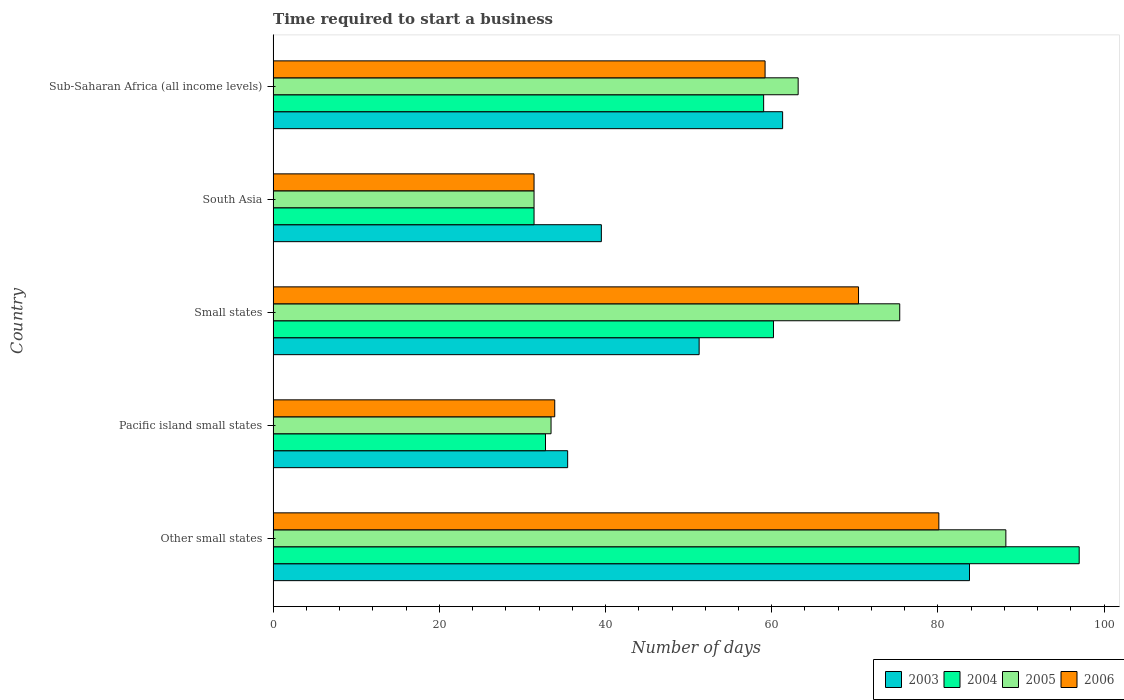How many groups of bars are there?
Your answer should be very brief. 5. Are the number of bars on each tick of the Y-axis equal?
Ensure brevity in your answer.  Yes. How many bars are there on the 2nd tick from the top?
Make the answer very short. 4. What is the label of the 2nd group of bars from the top?
Offer a terse response. South Asia. What is the number of days required to start a business in 2005 in Sub-Saharan Africa (all income levels)?
Offer a very short reply. 63.18. Across all countries, what is the maximum number of days required to start a business in 2006?
Ensure brevity in your answer.  80.11. Across all countries, what is the minimum number of days required to start a business in 2005?
Keep it short and to the point. 31.4. In which country was the number of days required to start a business in 2005 maximum?
Provide a succinct answer. Other small states. In which country was the number of days required to start a business in 2005 minimum?
Offer a very short reply. South Asia. What is the total number of days required to start a business in 2004 in the graph?
Ensure brevity in your answer.  280.42. What is the difference between the number of days required to start a business in 2005 in Pacific island small states and that in Small states?
Provide a short and direct response. -41.96. What is the difference between the number of days required to start a business in 2005 in Pacific island small states and the number of days required to start a business in 2003 in Other small states?
Provide a short and direct response. -50.36. What is the average number of days required to start a business in 2006 per country?
Provide a succinct answer. 55.01. What is the difference between the number of days required to start a business in 2006 and number of days required to start a business in 2004 in South Asia?
Make the answer very short. 0. What is the ratio of the number of days required to start a business in 2006 in Small states to that in South Asia?
Provide a short and direct response. 2.24. Is the number of days required to start a business in 2005 in South Asia less than that in Sub-Saharan Africa (all income levels)?
Offer a very short reply. Yes. What is the difference between the highest and the second highest number of days required to start a business in 2006?
Offer a very short reply. 9.66. What is the difference between the highest and the lowest number of days required to start a business in 2004?
Your answer should be very brief. 65.6. Is it the case that in every country, the sum of the number of days required to start a business in 2005 and number of days required to start a business in 2004 is greater than the sum of number of days required to start a business in 2006 and number of days required to start a business in 2003?
Your answer should be compact. No. How many bars are there?
Offer a very short reply. 20. How many countries are there in the graph?
Offer a very short reply. 5. What is the difference between two consecutive major ticks on the X-axis?
Your answer should be very brief. 20. Are the values on the major ticks of X-axis written in scientific E-notation?
Provide a succinct answer. No. Does the graph contain grids?
Ensure brevity in your answer.  No. What is the title of the graph?
Offer a very short reply. Time required to start a business. What is the label or title of the X-axis?
Keep it short and to the point. Number of days. What is the label or title of the Y-axis?
Offer a very short reply. Country. What is the Number of days in 2003 in Other small states?
Your answer should be compact. 83.8. What is the Number of days in 2004 in Other small states?
Ensure brevity in your answer.  97. What is the Number of days in 2005 in Other small states?
Provide a short and direct response. 88.18. What is the Number of days of 2006 in Other small states?
Offer a terse response. 80.11. What is the Number of days of 2003 in Pacific island small states?
Give a very brief answer. 35.44. What is the Number of days in 2004 in Pacific island small states?
Provide a succinct answer. 32.78. What is the Number of days in 2005 in Pacific island small states?
Your answer should be very brief. 33.44. What is the Number of days of 2006 in Pacific island small states?
Make the answer very short. 33.89. What is the Number of days of 2003 in Small states?
Your response must be concise. 51.27. What is the Number of days in 2004 in Small states?
Your answer should be compact. 60.21. What is the Number of days in 2005 in Small states?
Give a very brief answer. 75.41. What is the Number of days of 2006 in Small states?
Provide a short and direct response. 70.45. What is the Number of days in 2003 in South Asia?
Your answer should be compact. 39.5. What is the Number of days in 2004 in South Asia?
Provide a short and direct response. 31.4. What is the Number of days of 2005 in South Asia?
Your response must be concise. 31.4. What is the Number of days of 2006 in South Asia?
Provide a succinct answer. 31.4. What is the Number of days of 2003 in Sub-Saharan Africa (all income levels)?
Your answer should be compact. 61.31. What is the Number of days of 2004 in Sub-Saharan Africa (all income levels)?
Provide a short and direct response. 59.03. What is the Number of days in 2005 in Sub-Saharan Africa (all income levels)?
Keep it short and to the point. 63.18. What is the Number of days of 2006 in Sub-Saharan Africa (all income levels)?
Ensure brevity in your answer.  59.2. Across all countries, what is the maximum Number of days in 2003?
Your answer should be compact. 83.8. Across all countries, what is the maximum Number of days of 2004?
Your response must be concise. 97. Across all countries, what is the maximum Number of days in 2005?
Offer a terse response. 88.18. Across all countries, what is the maximum Number of days of 2006?
Provide a succinct answer. 80.11. Across all countries, what is the minimum Number of days of 2003?
Give a very brief answer. 35.44. Across all countries, what is the minimum Number of days of 2004?
Your answer should be compact. 31.4. Across all countries, what is the minimum Number of days in 2005?
Your answer should be compact. 31.4. Across all countries, what is the minimum Number of days of 2006?
Provide a short and direct response. 31.4. What is the total Number of days in 2003 in the graph?
Your answer should be very brief. 271.32. What is the total Number of days of 2004 in the graph?
Your answer should be very brief. 280.42. What is the total Number of days of 2005 in the graph?
Your answer should be compact. 291.61. What is the total Number of days in 2006 in the graph?
Keep it short and to the point. 275.05. What is the difference between the Number of days in 2003 in Other small states and that in Pacific island small states?
Offer a terse response. 48.36. What is the difference between the Number of days in 2004 in Other small states and that in Pacific island small states?
Ensure brevity in your answer.  64.22. What is the difference between the Number of days in 2005 in Other small states and that in Pacific island small states?
Ensure brevity in your answer.  54.73. What is the difference between the Number of days of 2006 in Other small states and that in Pacific island small states?
Provide a short and direct response. 46.22. What is the difference between the Number of days of 2003 in Other small states and that in Small states?
Make the answer very short. 32.53. What is the difference between the Number of days in 2004 in Other small states and that in Small states?
Provide a succinct answer. 36.79. What is the difference between the Number of days of 2005 in Other small states and that in Small states?
Keep it short and to the point. 12.77. What is the difference between the Number of days in 2006 in Other small states and that in Small states?
Provide a short and direct response. 9.66. What is the difference between the Number of days in 2003 in Other small states and that in South Asia?
Provide a short and direct response. 44.3. What is the difference between the Number of days in 2004 in Other small states and that in South Asia?
Keep it short and to the point. 65.6. What is the difference between the Number of days of 2005 in Other small states and that in South Asia?
Your answer should be very brief. 56.78. What is the difference between the Number of days in 2006 in Other small states and that in South Asia?
Make the answer very short. 48.71. What is the difference between the Number of days of 2003 in Other small states and that in Sub-Saharan Africa (all income levels)?
Keep it short and to the point. 22.49. What is the difference between the Number of days in 2004 in Other small states and that in Sub-Saharan Africa (all income levels)?
Your answer should be compact. 37.97. What is the difference between the Number of days of 2005 in Other small states and that in Sub-Saharan Africa (all income levels)?
Your answer should be compact. 24.99. What is the difference between the Number of days in 2006 in Other small states and that in Sub-Saharan Africa (all income levels)?
Your response must be concise. 20.91. What is the difference between the Number of days in 2003 in Pacific island small states and that in Small states?
Provide a succinct answer. -15.82. What is the difference between the Number of days of 2004 in Pacific island small states and that in Small states?
Provide a short and direct response. -27.43. What is the difference between the Number of days of 2005 in Pacific island small states and that in Small states?
Your response must be concise. -41.96. What is the difference between the Number of days in 2006 in Pacific island small states and that in Small states?
Make the answer very short. -36.56. What is the difference between the Number of days in 2003 in Pacific island small states and that in South Asia?
Offer a very short reply. -4.06. What is the difference between the Number of days of 2004 in Pacific island small states and that in South Asia?
Your answer should be compact. 1.38. What is the difference between the Number of days in 2005 in Pacific island small states and that in South Asia?
Provide a short and direct response. 2.04. What is the difference between the Number of days of 2006 in Pacific island small states and that in South Asia?
Ensure brevity in your answer.  2.49. What is the difference between the Number of days in 2003 in Pacific island small states and that in Sub-Saharan Africa (all income levels)?
Provide a short and direct response. -25.87. What is the difference between the Number of days in 2004 in Pacific island small states and that in Sub-Saharan Africa (all income levels)?
Keep it short and to the point. -26.25. What is the difference between the Number of days in 2005 in Pacific island small states and that in Sub-Saharan Africa (all income levels)?
Make the answer very short. -29.74. What is the difference between the Number of days of 2006 in Pacific island small states and that in Sub-Saharan Africa (all income levels)?
Provide a short and direct response. -25.31. What is the difference between the Number of days in 2003 in Small states and that in South Asia?
Your answer should be compact. 11.77. What is the difference between the Number of days in 2004 in Small states and that in South Asia?
Provide a succinct answer. 28.81. What is the difference between the Number of days of 2005 in Small states and that in South Asia?
Offer a very short reply. 44.01. What is the difference between the Number of days of 2006 in Small states and that in South Asia?
Offer a terse response. 39.05. What is the difference between the Number of days of 2003 in Small states and that in Sub-Saharan Africa (all income levels)?
Your answer should be very brief. -10.05. What is the difference between the Number of days in 2004 in Small states and that in Sub-Saharan Africa (all income levels)?
Your answer should be compact. 1.18. What is the difference between the Number of days in 2005 in Small states and that in Sub-Saharan Africa (all income levels)?
Offer a terse response. 12.22. What is the difference between the Number of days in 2006 in Small states and that in Sub-Saharan Africa (all income levels)?
Provide a succinct answer. 11.25. What is the difference between the Number of days of 2003 in South Asia and that in Sub-Saharan Africa (all income levels)?
Your answer should be compact. -21.81. What is the difference between the Number of days in 2004 in South Asia and that in Sub-Saharan Africa (all income levels)?
Provide a succinct answer. -27.63. What is the difference between the Number of days of 2005 in South Asia and that in Sub-Saharan Africa (all income levels)?
Ensure brevity in your answer.  -31.78. What is the difference between the Number of days in 2006 in South Asia and that in Sub-Saharan Africa (all income levels)?
Keep it short and to the point. -27.8. What is the difference between the Number of days in 2003 in Other small states and the Number of days in 2004 in Pacific island small states?
Your response must be concise. 51.02. What is the difference between the Number of days in 2003 in Other small states and the Number of days in 2005 in Pacific island small states?
Provide a short and direct response. 50.36. What is the difference between the Number of days in 2003 in Other small states and the Number of days in 2006 in Pacific island small states?
Your answer should be compact. 49.91. What is the difference between the Number of days in 2004 in Other small states and the Number of days in 2005 in Pacific island small states?
Offer a terse response. 63.56. What is the difference between the Number of days of 2004 in Other small states and the Number of days of 2006 in Pacific island small states?
Offer a terse response. 63.11. What is the difference between the Number of days in 2005 in Other small states and the Number of days in 2006 in Pacific island small states?
Your answer should be very brief. 54.29. What is the difference between the Number of days in 2003 in Other small states and the Number of days in 2004 in Small states?
Your response must be concise. 23.59. What is the difference between the Number of days in 2003 in Other small states and the Number of days in 2005 in Small states?
Keep it short and to the point. 8.39. What is the difference between the Number of days in 2003 in Other small states and the Number of days in 2006 in Small states?
Offer a very short reply. 13.35. What is the difference between the Number of days of 2004 in Other small states and the Number of days of 2005 in Small states?
Keep it short and to the point. 21.59. What is the difference between the Number of days of 2004 in Other small states and the Number of days of 2006 in Small states?
Give a very brief answer. 26.55. What is the difference between the Number of days of 2005 in Other small states and the Number of days of 2006 in Small states?
Your response must be concise. 17.73. What is the difference between the Number of days in 2003 in Other small states and the Number of days in 2004 in South Asia?
Your answer should be compact. 52.4. What is the difference between the Number of days in 2003 in Other small states and the Number of days in 2005 in South Asia?
Keep it short and to the point. 52.4. What is the difference between the Number of days in 2003 in Other small states and the Number of days in 2006 in South Asia?
Provide a short and direct response. 52.4. What is the difference between the Number of days in 2004 in Other small states and the Number of days in 2005 in South Asia?
Make the answer very short. 65.6. What is the difference between the Number of days of 2004 in Other small states and the Number of days of 2006 in South Asia?
Your response must be concise. 65.6. What is the difference between the Number of days of 2005 in Other small states and the Number of days of 2006 in South Asia?
Provide a succinct answer. 56.78. What is the difference between the Number of days of 2003 in Other small states and the Number of days of 2004 in Sub-Saharan Africa (all income levels)?
Keep it short and to the point. 24.77. What is the difference between the Number of days in 2003 in Other small states and the Number of days in 2005 in Sub-Saharan Africa (all income levels)?
Ensure brevity in your answer.  20.62. What is the difference between the Number of days in 2003 in Other small states and the Number of days in 2006 in Sub-Saharan Africa (all income levels)?
Ensure brevity in your answer.  24.6. What is the difference between the Number of days of 2004 in Other small states and the Number of days of 2005 in Sub-Saharan Africa (all income levels)?
Keep it short and to the point. 33.82. What is the difference between the Number of days in 2004 in Other small states and the Number of days in 2006 in Sub-Saharan Africa (all income levels)?
Make the answer very short. 37.8. What is the difference between the Number of days of 2005 in Other small states and the Number of days of 2006 in Sub-Saharan Africa (all income levels)?
Offer a terse response. 28.98. What is the difference between the Number of days of 2003 in Pacific island small states and the Number of days of 2004 in Small states?
Make the answer very short. -24.77. What is the difference between the Number of days in 2003 in Pacific island small states and the Number of days in 2005 in Small states?
Your answer should be compact. -39.96. What is the difference between the Number of days of 2003 in Pacific island small states and the Number of days of 2006 in Small states?
Ensure brevity in your answer.  -35. What is the difference between the Number of days in 2004 in Pacific island small states and the Number of days in 2005 in Small states?
Offer a terse response. -42.63. What is the difference between the Number of days in 2004 in Pacific island small states and the Number of days in 2006 in Small states?
Offer a very short reply. -37.67. What is the difference between the Number of days in 2005 in Pacific island small states and the Number of days in 2006 in Small states?
Provide a succinct answer. -37. What is the difference between the Number of days of 2003 in Pacific island small states and the Number of days of 2004 in South Asia?
Your answer should be compact. 4.04. What is the difference between the Number of days in 2003 in Pacific island small states and the Number of days in 2005 in South Asia?
Keep it short and to the point. 4.04. What is the difference between the Number of days in 2003 in Pacific island small states and the Number of days in 2006 in South Asia?
Make the answer very short. 4.04. What is the difference between the Number of days of 2004 in Pacific island small states and the Number of days of 2005 in South Asia?
Offer a terse response. 1.38. What is the difference between the Number of days of 2004 in Pacific island small states and the Number of days of 2006 in South Asia?
Your answer should be very brief. 1.38. What is the difference between the Number of days of 2005 in Pacific island small states and the Number of days of 2006 in South Asia?
Offer a very short reply. 2.04. What is the difference between the Number of days in 2003 in Pacific island small states and the Number of days in 2004 in Sub-Saharan Africa (all income levels)?
Make the answer very short. -23.58. What is the difference between the Number of days in 2003 in Pacific island small states and the Number of days in 2005 in Sub-Saharan Africa (all income levels)?
Ensure brevity in your answer.  -27.74. What is the difference between the Number of days of 2003 in Pacific island small states and the Number of days of 2006 in Sub-Saharan Africa (all income levels)?
Provide a short and direct response. -23.76. What is the difference between the Number of days of 2004 in Pacific island small states and the Number of days of 2005 in Sub-Saharan Africa (all income levels)?
Offer a very short reply. -30.4. What is the difference between the Number of days in 2004 in Pacific island small states and the Number of days in 2006 in Sub-Saharan Africa (all income levels)?
Give a very brief answer. -26.42. What is the difference between the Number of days in 2005 in Pacific island small states and the Number of days in 2006 in Sub-Saharan Africa (all income levels)?
Ensure brevity in your answer.  -25.76. What is the difference between the Number of days in 2003 in Small states and the Number of days in 2004 in South Asia?
Keep it short and to the point. 19.87. What is the difference between the Number of days of 2003 in Small states and the Number of days of 2005 in South Asia?
Provide a short and direct response. 19.87. What is the difference between the Number of days in 2003 in Small states and the Number of days in 2006 in South Asia?
Keep it short and to the point. 19.87. What is the difference between the Number of days in 2004 in Small states and the Number of days in 2005 in South Asia?
Offer a terse response. 28.81. What is the difference between the Number of days in 2004 in Small states and the Number of days in 2006 in South Asia?
Provide a succinct answer. 28.81. What is the difference between the Number of days in 2005 in Small states and the Number of days in 2006 in South Asia?
Your response must be concise. 44.01. What is the difference between the Number of days in 2003 in Small states and the Number of days in 2004 in Sub-Saharan Africa (all income levels)?
Give a very brief answer. -7.76. What is the difference between the Number of days in 2003 in Small states and the Number of days in 2005 in Sub-Saharan Africa (all income levels)?
Provide a short and direct response. -11.92. What is the difference between the Number of days of 2003 in Small states and the Number of days of 2006 in Sub-Saharan Africa (all income levels)?
Ensure brevity in your answer.  -7.93. What is the difference between the Number of days of 2004 in Small states and the Number of days of 2005 in Sub-Saharan Africa (all income levels)?
Your answer should be very brief. -2.97. What is the difference between the Number of days in 2004 in Small states and the Number of days in 2006 in Sub-Saharan Africa (all income levels)?
Provide a short and direct response. 1.01. What is the difference between the Number of days in 2005 in Small states and the Number of days in 2006 in Sub-Saharan Africa (all income levels)?
Ensure brevity in your answer.  16.21. What is the difference between the Number of days of 2003 in South Asia and the Number of days of 2004 in Sub-Saharan Africa (all income levels)?
Provide a succinct answer. -19.53. What is the difference between the Number of days of 2003 in South Asia and the Number of days of 2005 in Sub-Saharan Africa (all income levels)?
Keep it short and to the point. -23.68. What is the difference between the Number of days in 2003 in South Asia and the Number of days in 2006 in Sub-Saharan Africa (all income levels)?
Ensure brevity in your answer.  -19.7. What is the difference between the Number of days in 2004 in South Asia and the Number of days in 2005 in Sub-Saharan Africa (all income levels)?
Your answer should be very brief. -31.78. What is the difference between the Number of days in 2004 in South Asia and the Number of days in 2006 in Sub-Saharan Africa (all income levels)?
Provide a succinct answer. -27.8. What is the difference between the Number of days of 2005 in South Asia and the Number of days of 2006 in Sub-Saharan Africa (all income levels)?
Give a very brief answer. -27.8. What is the average Number of days in 2003 per country?
Offer a terse response. 54.26. What is the average Number of days in 2004 per country?
Your answer should be compact. 56.08. What is the average Number of days in 2005 per country?
Keep it short and to the point. 58.32. What is the average Number of days in 2006 per country?
Your answer should be very brief. 55.01. What is the difference between the Number of days of 2003 and Number of days of 2004 in Other small states?
Offer a very short reply. -13.2. What is the difference between the Number of days of 2003 and Number of days of 2005 in Other small states?
Provide a succinct answer. -4.38. What is the difference between the Number of days in 2003 and Number of days in 2006 in Other small states?
Your response must be concise. 3.69. What is the difference between the Number of days in 2004 and Number of days in 2005 in Other small states?
Give a very brief answer. 8.82. What is the difference between the Number of days of 2004 and Number of days of 2006 in Other small states?
Offer a very short reply. 16.89. What is the difference between the Number of days of 2005 and Number of days of 2006 in Other small states?
Keep it short and to the point. 8.07. What is the difference between the Number of days of 2003 and Number of days of 2004 in Pacific island small states?
Offer a terse response. 2.67. What is the difference between the Number of days in 2003 and Number of days in 2005 in Pacific island small states?
Make the answer very short. 2. What is the difference between the Number of days in 2003 and Number of days in 2006 in Pacific island small states?
Your response must be concise. 1.56. What is the difference between the Number of days in 2004 and Number of days in 2006 in Pacific island small states?
Offer a very short reply. -1.11. What is the difference between the Number of days of 2005 and Number of days of 2006 in Pacific island small states?
Keep it short and to the point. -0.44. What is the difference between the Number of days in 2003 and Number of days in 2004 in Small states?
Your answer should be very brief. -8.94. What is the difference between the Number of days in 2003 and Number of days in 2005 in Small states?
Ensure brevity in your answer.  -24.14. What is the difference between the Number of days in 2003 and Number of days in 2006 in Small states?
Ensure brevity in your answer.  -19.18. What is the difference between the Number of days in 2004 and Number of days in 2005 in Small states?
Provide a succinct answer. -15.19. What is the difference between the Number of days in 2004 and Number of days in 2006 in Small states?
Keep it short and to the point. -10.24. What is the difference between the Number of days in 2005 and Number of days in 2006 in Small states?
Offer a terse response. 4.96. What is the difference between the Number of days of 2003 and Number of days of 2005 in South Asia?
Your response must be concise. 8.1. What is the difference between the Number of days of 2003 and Number of days of 2004 in Sub-Saharan Africa (all income levels)?
Ensure brevity in your answer.  2.28. What is the difference between the Number of days of 2003 and Number of days of 2005 in Sub-Saharan Africa (all income levels)?
Your response must be concise. -1.87. What is the difference between the Number of days in 2003 and Number of days in 2006 in Sub-Saharan Africa (all income levels)?
Provide a short and direct response. 2.11. What is the difference between the Number of days of 2004 and Number of days of 2005 in Sub-Saharan Africa (all income levels)?
Make the answer very short. -4.15. What is the difference between the Number of days of 2004 and Number of days of 2006 in Sub-Saharan Africa (all income levels)?
Keep it short and to the point. -0.17. What is the difference between the Number of days of 2005 and Number of days of 2006 in Sub-Saharan Africa (all income levels)?
Provide a succinct answer. 3.98. What is the ratio of the Number of days of 2003 in Other small states to that in Pacific island small states?
Make the answer very short. 2.36. What is the ratio of the Number of days in 2004 in Other small states to that in Pacific island small states?
Ensure brevity in your answer.  2.96. What is the ratio of the Number of days in 2005 in Other small states to that in Pacific island small states?
Your response must be concise. 2.64. What is the ratio of the Number of days in 2006 in Other small states to that in Pacific island small states?
Keep it short and to the point. 2.36. What is the ratio of the Number of days of 2003 in Other small states to that in Small states?
Offer a very short reply. 1.63. What is the ratio of the Number of days in 2004 in Other small states to that in Small states?
Your answer should be compact. 1.61. What is the ratio of the Number of days in 2005 in Other small states to that in Small states?
Your answer should be compact. 1.17. What is the ratio of the Number of days of 2006 in Other small states to that in Small states?
Your response must be concise. 1.14. What is the ratio of the Number of days of 2003 in Other small states to that in South Asia?
Your answer should be compact. 2.12. What is the ratio of the Number of days in 2004 in Other small states to that in South Asia?
Your response must be concise. 3.09. What is the ratio of the Number of days of 2005 in Other small states to that in South Asia?
Make the answer very short. 2.81. What is the ratio of the Number of days of 2006 in Other small states to that in South Asia?
Your response must be concise. 2.55. What is the ratio of the Number of days of 2003 in Other small states to that in Sub-Saharan Africa (all income levels)?
Your answer should be very brief. 1.37. What is the ratio of the Number of days of 2004 in Other small states to that in Sub-Saharan Africa (all income levels)?
Your answer should be compact. 1.64. What is the ratio of the Number of days of 2005 in Other small states to that in Sub-Saharan Africa (all income levels)?
Keep it short and to the point. 1.4. What is the ratio of the Number of days in 2006 in Other small states to that in Sub-Saharan Africa (all income levels)?
Your answer should be very brief. 1.35. What is the ratio of the Number of days in 2003 in Pacific island small states to that in Small states?
Provide a succinct answer. 0.69. What is the ratio of the Number of days in 2004 in Pacific island small states to that in Small states?
Your answer should be compact. 0.54. What is the ratio of the Number of days of 2005 in Pacific island small states to that in Small states?
Provide a short and direct response. 0.44. What is the ratio of the Number of days in 2006 in Pacific island small states to that in Small states?
Provide a short and direct response. 0.48. What is the ratio of the Number of days in 2003 in Pacific island small states to that in South Asia?
Your response must be concise. 0.9. What is the ratio of the Number of days in 2004 in Pacific island small states to that in South Asia?
Your response must be concise. 1.04. What is the ratio of the Number of days of 2005 in Pacific island small states to that in South Asia?
Keep it short and to the point. 1.07. What is the ratio of the Number of days of 2006 in Pacific island small states to that in South Asia?
Make the answer very short. 1.08. What is the ratio of the Number of days in 2003 in Pacific island small states to that in Sub-Saharan Africa (all income levels)?
Make the answer very short. 0.58. What is the ratio of the Number of days of 2004 in Pacific island small states to that in Sub-Saharan Africa (all income levels)?
Offer a very short reply. 0.56. What is the ratio of the Number of days in 2005 in Pacific island small states to that in Sub-Saharan Africa (all income levels)?
Offer a very short reply. 0.53. What is the ratio of the Number of days of 2006 in Pacific island small states to that in Sub-Saharan Africa (all income levels)?
Keep it short and to the point. 0.57. What is the ratio of the Number of days of 2003 in Small states to that in South Asia?
Your answer should be compact. 1.3. What is the ratio of the Number of days of 2004 in Small states to that in South Asia?
Offer a very short reply. 1.92. What is the ratio of the Number of days in 2005 in Small states to that in South Asia?
Your answer should be compact. 2.4. What is the ratio of the Number of days in 2006 in Small states to that in South Asia?
Keep it short and to the point. 2.24. What is the ratio of the Number of days of 2003 in Small states to that in Sub-Saharan Africa (all income levels)?
Ensure brevity in your answer.  0.84. What is the ratio of the Number of days of 2005 in Small states to that in Sub-Saharan Africa (all income levels)?
Offer a very short reply. 1.19. What is the ratio of the Number of days of 2006 in Small states to that in Sub-Saharan Africa (all income levels)?
Give a very brief answer. 1.19. What is the ratio of the Number of days in 2003 in South Asia to that in Sub-Saharan Africa (all income levels)?
Keep it short and to the point. 0.64. What is the ratio of the Number of days of 2004 in South Asia to that in Sub-Saharan Africa (all income levels)?
Offer a very short reply. 0.53. What is the ratio of the Number of days in 2005 in South Asia to that in Sub-Saharan Africa (all income levels)?
Give a very brief answer. 0.5. What is the ratio of the Number of days in 2006 in South Asia to that in Sub-Saharan Africa (all income levels)?
Your response must be concise. 0.53. What is the difference between the highest and the second highest Number of days of 2003?
Offer a very short reply. 22.49. What is the difference between the highest and the second highest Number of days in 2004?
Give a very brief answer. 36.79. What is the difference between the highest and the second highest Number of days of 2005?
Make the answer very short. 12.77. What is the difference between the highest and the second highest Number of days of 2006?
Provide a succinct answer. 9.66. What is the difference between the highest and the lowest Number of days of 2003?
Make the answer very short. 48.36. What is the difference between the highest and the lowest Number of days of 2004?
Give a very brief answer. 65.6. What is the difference between the highest and the lowest Number of days of 2005?
Provide a succinct answer. 56.78. What is the difference between the highest and the lowest Number of days of 2006?
Offer a very short reply. 48.71. 